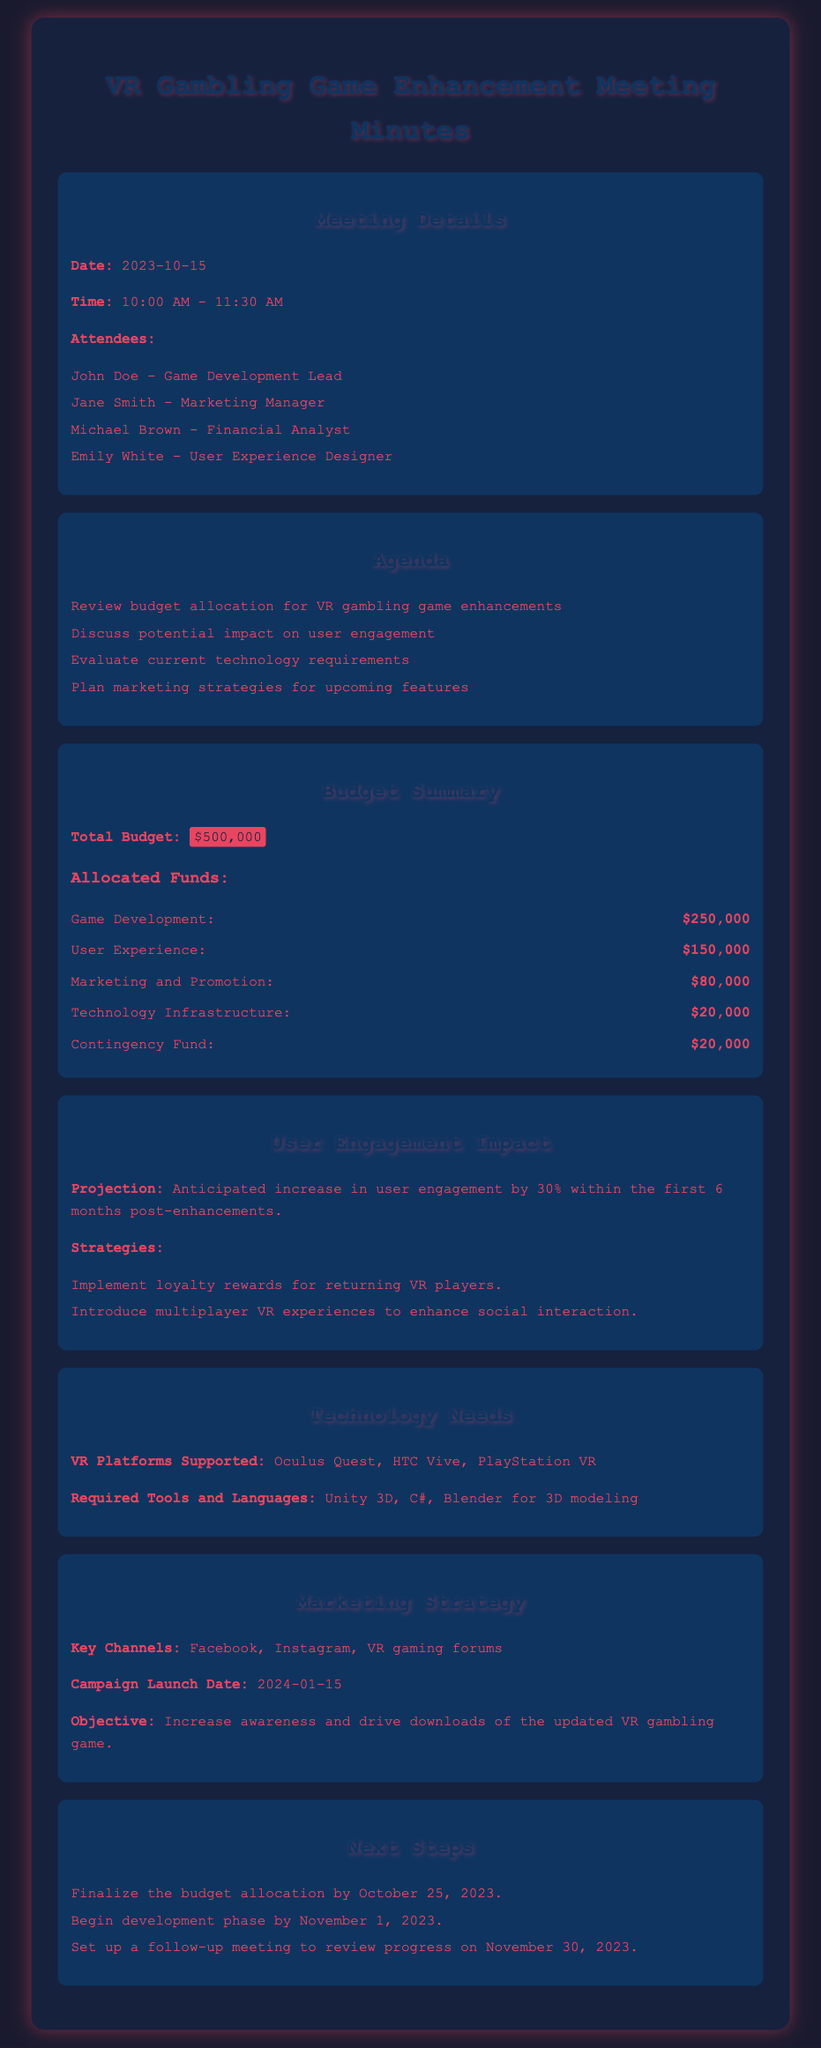What is the total budget? The total budget is specified in the document under the Budget Summary section as $500,000.
Answer: $500,000 Who is the Game Development Lead? The document lists John Doe as the Game Development Lead in the Meeting Details section.
Answer: John Doe How much is allocated for Marketing and Promotion? The allocated funds for Marketing and Promotion are outlined in the Budget Summary section as $80,000.
Answer: $80,000 What is the projected increase in user engagement? The document states an anticipated increase in user engagement by 30% within the first 6 months post-enhancements.
Answer: 30% What date is the campaign launch scheduled? The Marketing Strategy section specifies the Campaign Launch Date as 2024-01-15.
Answer: 2024-01-15 How much is allocated for User Experience? The Budget Summary section indicates that $150,000 is allocated for User Experience.
Answer: $150,000 What platforms will the VR gambling game support? The Technology Needs section lists Oculus Quest, HTC Vive, and PlayStation VR as supported VR platforms.
Answer: Oculus Quest, HTC Vive, PlayStation VR What is the objective of the marketing strategy? The Marketing Strategy section outlines the objective to increase awareness and drive downloads of the updated VR gambling game.
Answer: Increase awareness and drive downloads When is the follow-up meeting scheduled? The Next Steps section indicates the follow-up meeting is set for November 30, 2023.
Answer: November 30, 2023 